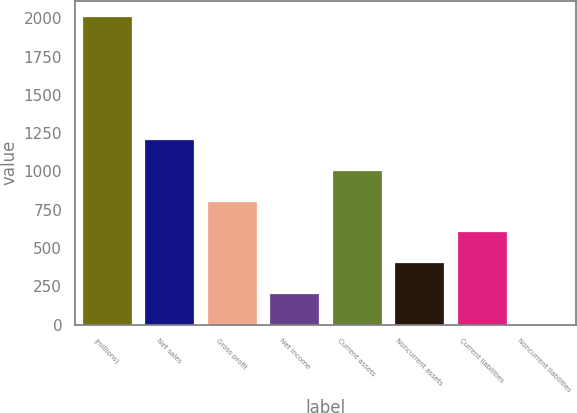Convert chart to OTSL. <chart><loc_0><loc_0><loc_500><loc_500><bar_chart><fcel>(millions)<fcel>Net sales<fcel>Gross profit<fcel>Net income<fcel>Current assets<fcel>Noncurrent assets<fcel>Current liabilities<fcel>Noncurrent liabilities<nl><fcel>2014<fcel>1210.92<fcel>809.38<fcel>207.07<fcel>1010.15<fcel>407.84<fcel>608.61<fcel>6.3<nl></chart> 